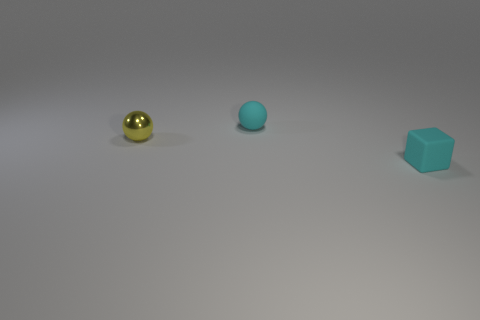Is there anything else that is the same size as the yellow thing?
Offer a very short reply. Yes. Are there any big gray matte objects?
Your answer should be very brief. No. There is a small cyan object left of the object that is right of the tiny cyan matte thing that is to the left of the rubber block; what is it made of?
Offer a terse response. Rubber. Does the yellow thing have the same shape as the cyan thing that is to the right of the tiny cyan rubber sphere?
Offer a very short reply. No. What number of small purple objects have the same shape as the yellow thing?
Give a very brief answer. 0. The small yellow metal object has what shape?
Ensure brevity in your answer.  Sphere. There is a cyan matte thing in front of the small yellow metallic thing that is behind the block; what is its size?
Offer a terse response. Small. How many objects are cyan spheres or big blue metal cylinders?
Offer a very short reply. 1. Is there a object that has the same material as the tiny cyan sphere?
Offer a very short reply. Yes. There is a small cyan rubber object that is behind the metallic sphere; are there any cyan rubber cubes in front of it?
Ensure brevity in your answer.  Yes. 